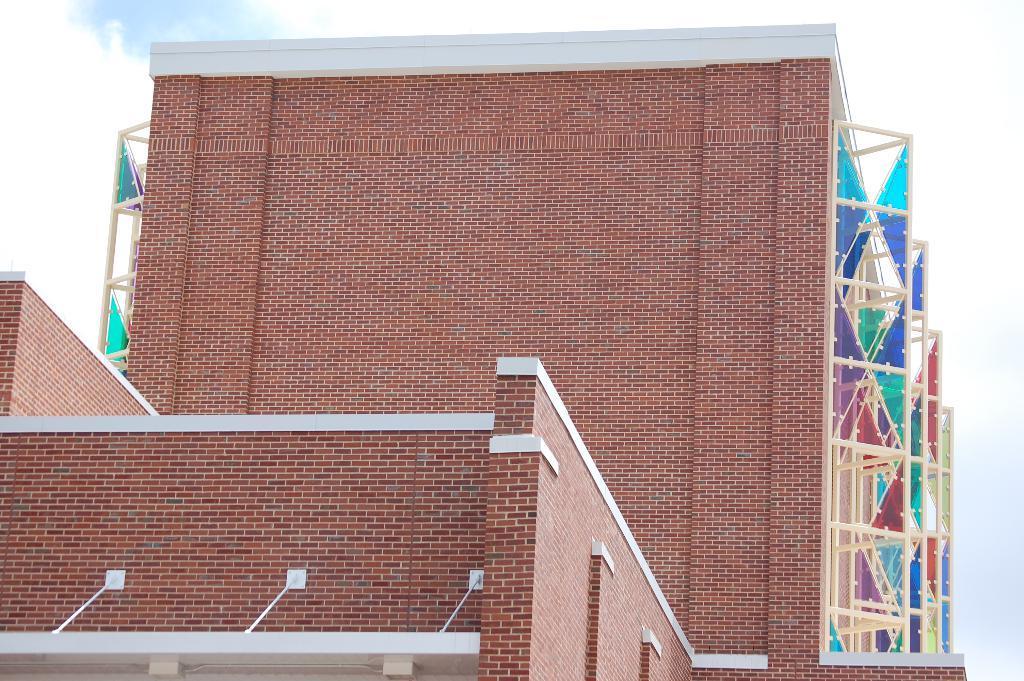Can you describe this image briefly? Here in this picture we can see buildings present and on either side of that we can see some frames present and we can also see clouds in the sky. 